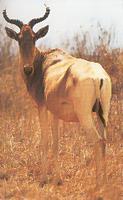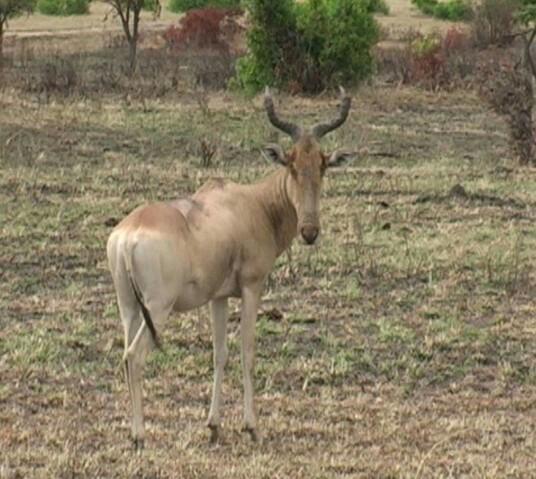The first image is the image on the left, the second image is the image on the right. Given the left and right images, does the statement "Each image contains just one horned animal, and the animals in the right and left images face away from each other." hold true? Answer yes or no. Yes. 